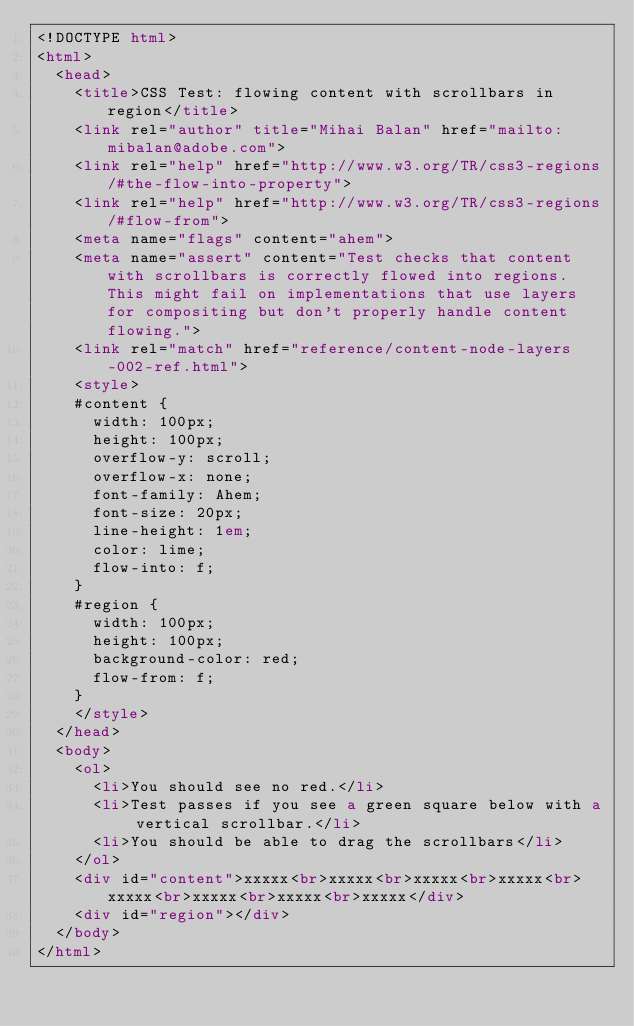Convert code to text. <code><loc_0><loc_0><loc_500><loc_500><_HTML_><!DOCTYPE html>
<html>
	<head>
		<title>CSS Test: flowing content with scrollbars in region</title>
		<link rel="author" title="Mihai Balan" href="mailto:mibalan@adobe.com">
		<link rel="help" href="http://www.w3.org/TR/css3-regions/#the-flow-into-property">
		<link rel="help" href="http://www.w3.org/TR/css3-regions/#flow-from">
		<meta name="flags" content="ahem">
		<meta name="assert" content="Test checks that content with scrollbars is correctly flowed into regions. This might fail on implementations that use layers for compositing but don't properly handle content flowing.">
		<link rel="match" href="reference/content-node-layers-002-ref.html">
		<style>
		#content {
			width: 100px;
			height: 100px;
			overflow-y: scroll;
			overflow-x: none;
			font-family: Ahem;
			font-size: 20px;
			line-height: 1em;
			color: lime;
			flow-into: f;
		}
		#region {
			width: 100px;
			height: 100px;
			background-color: red;
			flow-from: f;
		}
		</style>
	</head>
	<body>
		<ol>
			<li>You should see no red.</li>
			<li>Test passes if you see a green square below with a vertical scrollbar.</li>
			<li>You should be able to drag the scrollbars</li>
		</ol>
		<div id="content">xxxxx<br>xxxxx<br>xxxxx<br>xxxxx<br>xxxxx<br>xxxxx<br>xxxxx<br>xxxxx</div>
		<div id="region"></div>
	</body>
</html></code> 